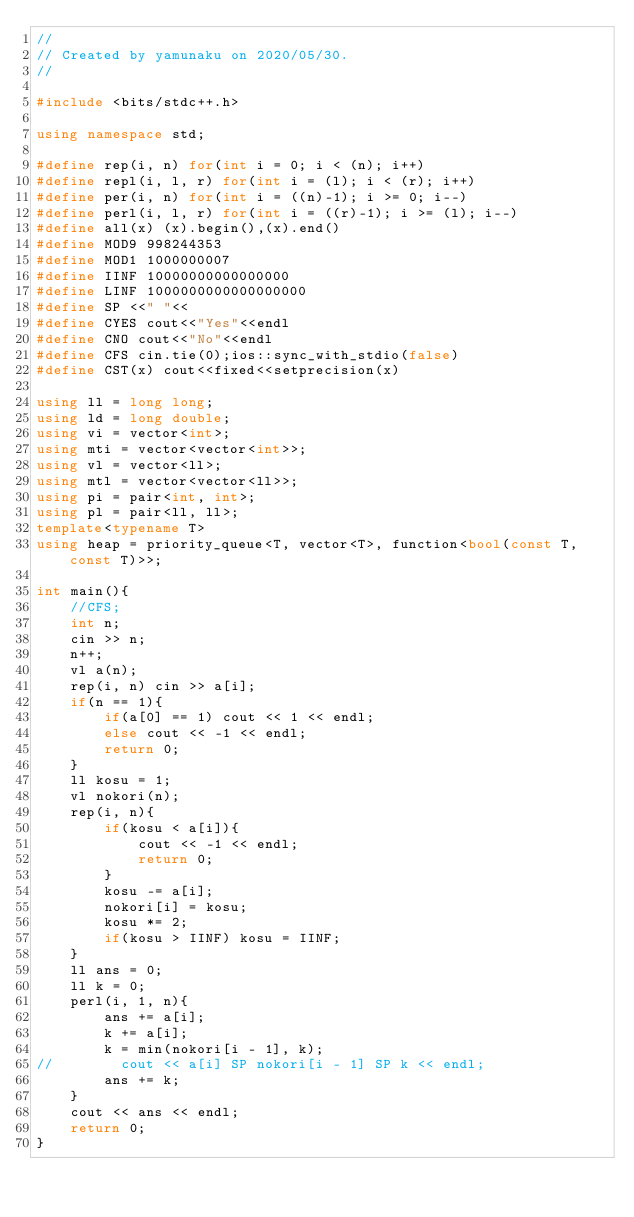Convert code to text. <code><loc_0><loc_0><loc_500><loc_500><_C++_>//
// Created by yamunaku on 2020/05/30.
//

#include <bits/stdc++.h>

using namespace std;

#define rep(i, n) for(int i = 0; i < (n); i++)
#define repl(i, l, r) for(int i = (l); i < (r); i++)
#define per(i, n) for(int i = ((n)-1); i >= 0; i--)
#define perl(i, l, r) for(int i = ((r)-1); i >= (l); i--)
#define all(x) (x).begin(),(x).end()
#define MOD9 998244353
#define MOD1 1000000007
#define IINF 10000000000000000
#define LINF 1000000000000000000
#define SP <<" "<<
#define CYES cout<<"Yes"<<endl
#define CNO cout<<"No"<<endl
#define CFS cin.tie(0);ios::sync_with_stdio(false)
#define CST(x) cout<<fixed<<setprecision(x)

using ll = long long;
using ld = long double;
using vi = vector<int>;
using mti = vector<vector<int>>;
using vl = vector<ll>;
using mtl = vector<vector<ll>>;
using pi = pair<int, int>;
using pl = pair<ll, ll>;
template<typename T>
using heap = priority_queue<T, vector<T>, function<bool(const T, const T)>>;

int main(){
    //CFS;
    int n;
    cin >> n;
    n++;
    vl a(n);
    rep(i, n) cin >> a[i];
    if(n == 1){
        if(a[0] == 1) cout << 1 << endl;
        else cout << -1 << endl;
        return 0;
    }
    ll kosu = 1;
    vl nokori(n);
    rep(i, n){
        if(kosu < a[i]){
            cout << -1 << endl;
            return 0;
        }
        kosu -= a[i];
        nokori[i] = kosu;
        kosu *= 2;
        if(kosu > IINF) kosu = IINF;
    }
    ll ans = 0;
    ll k = 0;
    perl(i, 1, n){
        ans += a[i];
        k += a[i];
        k = min(nokori[i - 1], k);
//        cout << a[i] SP nokori[i - 1] SP k << endl;
        ans += k;
    }
    cout << ans << endl;
    return 0;
}</code> 